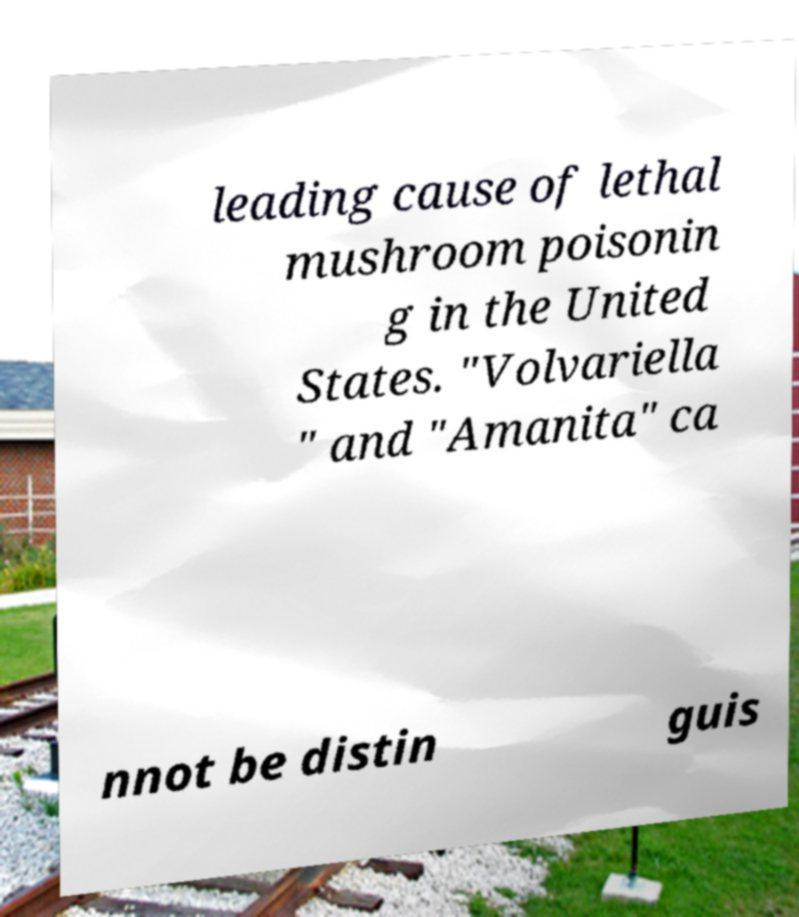Could you assist in decoding the text presented in this image and type it out clearly? leading cause of lethal mushroom poisonin g in the United States. "Volvariella " and "Amanita" ca nnot be distin guis 